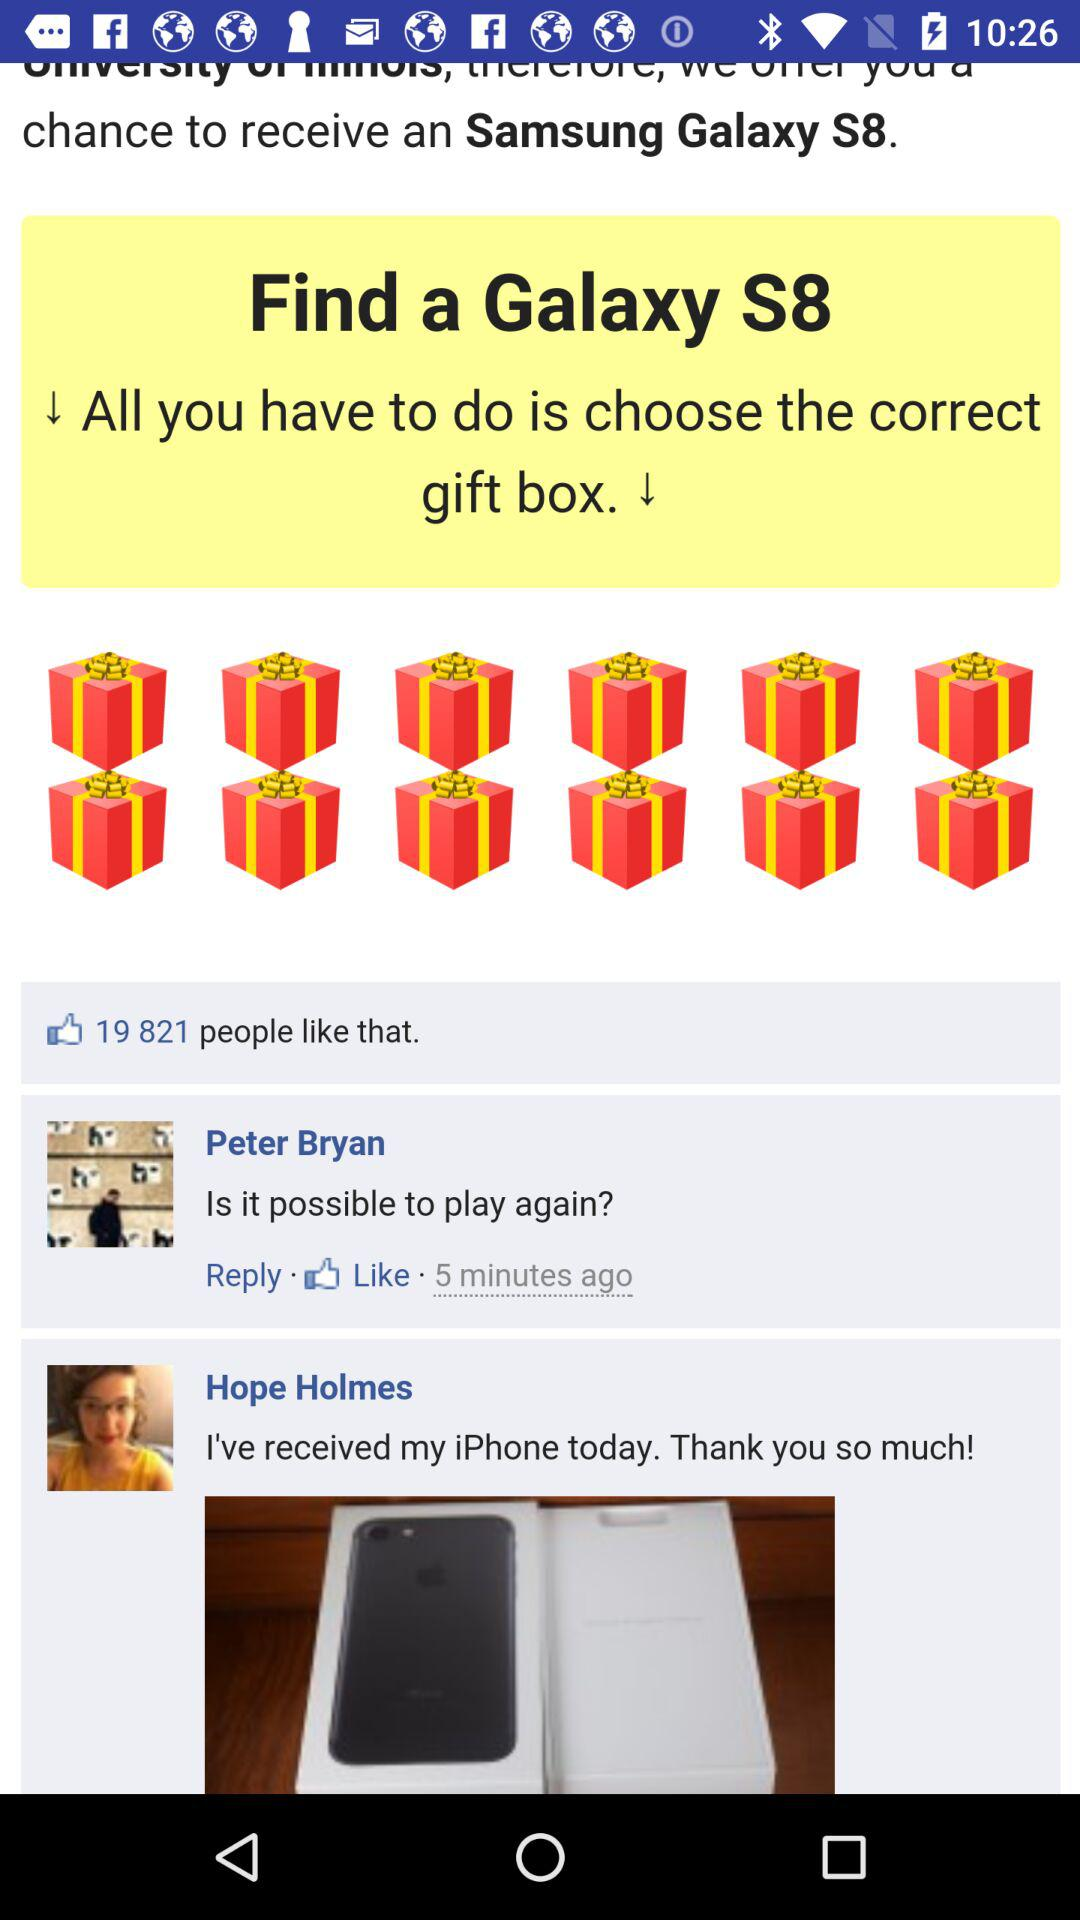How many comments are on the post?
Answer the question using a single word or phrase. 2 